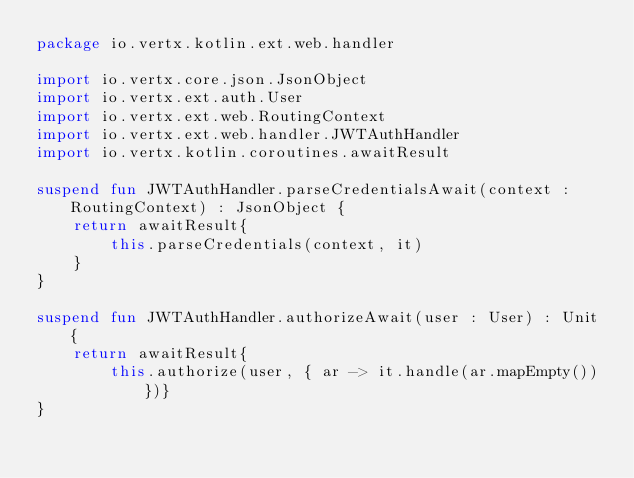Convert code to text. <code><loc_0><loc_0><loc_500><loc_500><_Kotlin_>package io.vertx.kotlin.ext.web.handler

import io.vertx.core.json.JsonObject
import io.vertx.ext.auth.User
import io.vertx.ext.web.RoutingContext
import io.vertx.ext.web.handler.JWTAuthHandler
import io.vertx.kotlin.coroutines.awaitResult

suspend fun JWTAuthHandler.parseCredentialsAwait(context : RoutingContext) : JsonObject {
    return awaitResult{
        this.parseCredentials(context, it)
    }
}

suspend fun JWTAuthHandler.authorizeAwait(user : User) : Unit {
    return awaitResult{
        this.authorize(user, { ar -> it.handle(ar.mapEmpty()) })}
}

</code> 